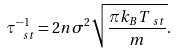Convert formula to latex. <formula><loc_0><loc_0><loc_500><loc_500>\tau _ { \ s t } ^ { - 1 } = 2 n \sigma ^ { 2 } \sqrt { \frac { \pi k _ { B } T _ { \ s t } } { m } } .</formula> 